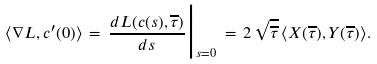<formula> <loc_0><loc_0><loc_500><loc_500>\langle \nabla L , c ^ { \prime } ( 0 ) \rangle \, = \, \frac { d L ( c ( s ) , \overline { \tau } ) } { d s } \Big | _ { s = 0 } \, = \, 2 \, \sqrt { \overline { \tau } } \, \langle X ( \overline { \tau } ) , Y ( \overline { \tau } ) \rangle .</formula> 